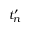<formula> <loc_0><loc_0><loc_500><loc_500>t _ { n } ^ { \prime }</formula> 